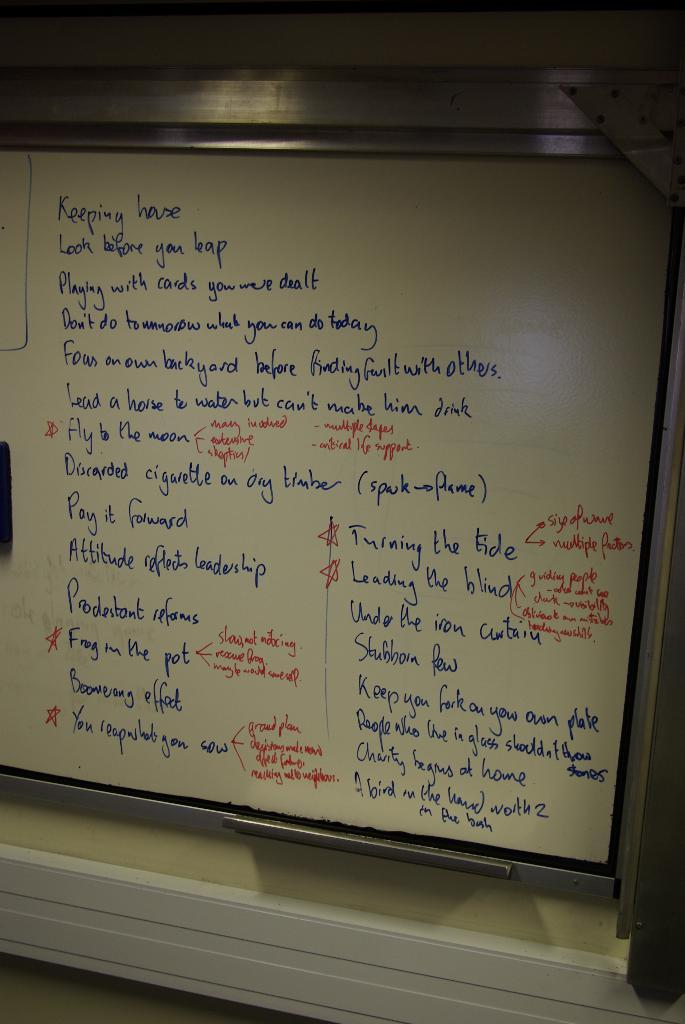<image>
Present a compact description of the photo's key features. A list on a whiteboard starts with "keeping house". 